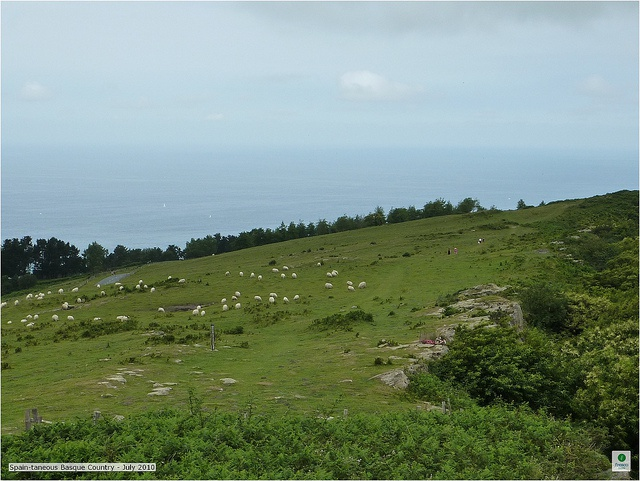Describe the objects in this image and their specific colors. I can see sheep in white, darkgreen, gray, and black tones, sheep in white, darkgreen, gray, and darkgray tones, sheep in white, darkgreen, gray, and darkgray tones, sheep in white, gray, darkgreen, and darkgray tones, and sheep in white, gray, darkgray, beige, and darkgreen tones in this image. 